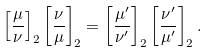Convert formula to latex. <formula><loc_0><loc_0><loc_500><loc_500>\left [ { \frac { \mu } { \nu } } \right ] _ { 2 } \left [ { \frac { \nu } { \mu } } \right ] _ { 2 } = \left [ { \frac { \mu ^ { \prime } } { \nu ^ { \prime } } } \right ] _ { 2 } \left [ { \frac { \nu ^ { \prime } } { \mu ^ { \prime } } } \right ] _ { 2 } .</formula> 